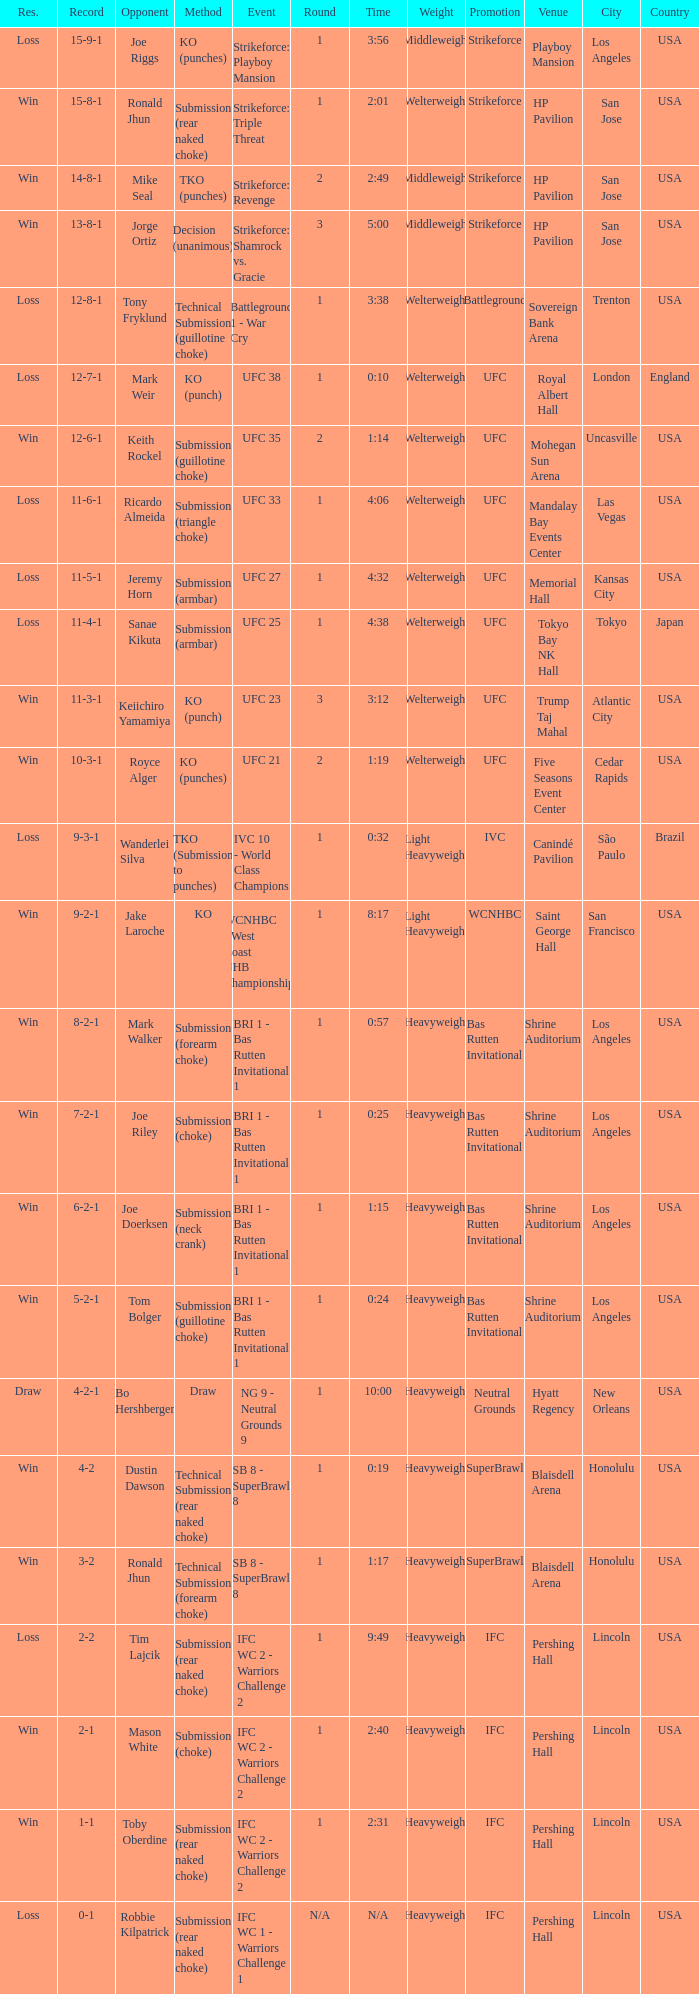What is the record when the fight was against keith rockel? 12-6-1. 